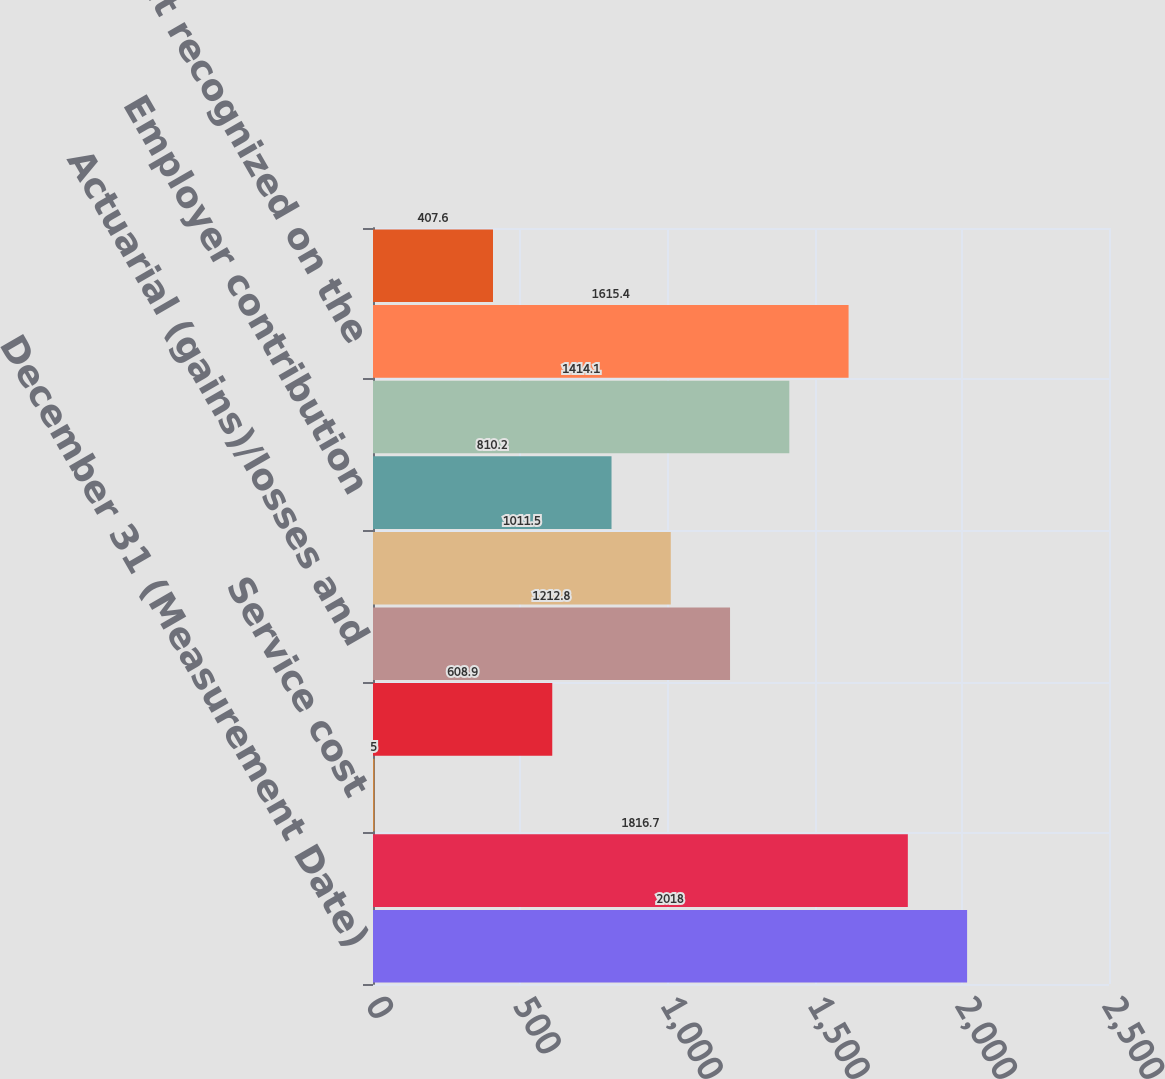Convert chart to OTSL. <chart><loc_0><loc_0><loc_500><loc_500><bar_chart><fcel>December 31 (Measurement Date)<fcel>Projected benefit obligation<fcel>Service cost<fcel>Interest cost<fcel>Actuarial (gains)/losses and<fcel>Benefits paid<fcel>Employer contribution<fcel>Funded status<fcel>Net amount recognized on the<fcel>Net actuarial loss (gain)<nl><fcel>2018<fcel>1816.7<fcel>5<fcel>608.9<fcel>1212.8<fcel>1011.5<fcel>810.2<fcel>1414.1<fcel>1615.4<fcel>407.6<nl></chart> 